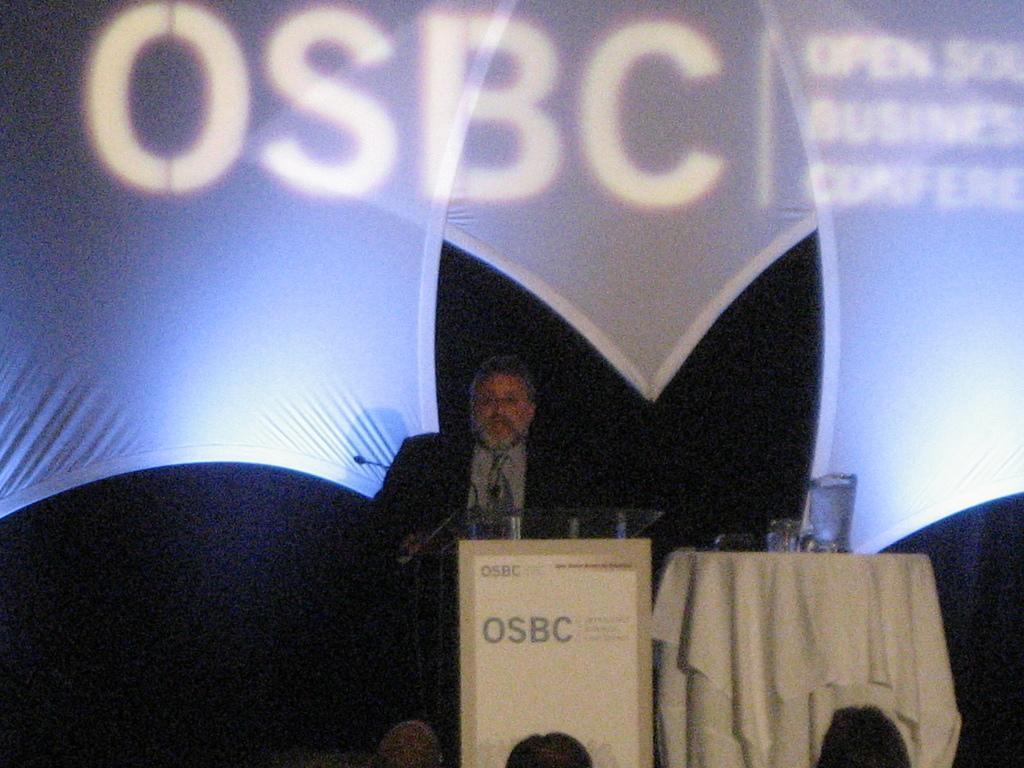Please provide a concise description of this image. In this image there is a man standing in front of a podium, on that podium there is some text written on the top their is mic, beside the podium there is a table on that table there is a cloth mug and glasses, in the background there is poster on that poster there is some text, in front of the podium there are people sitting on chairs. 